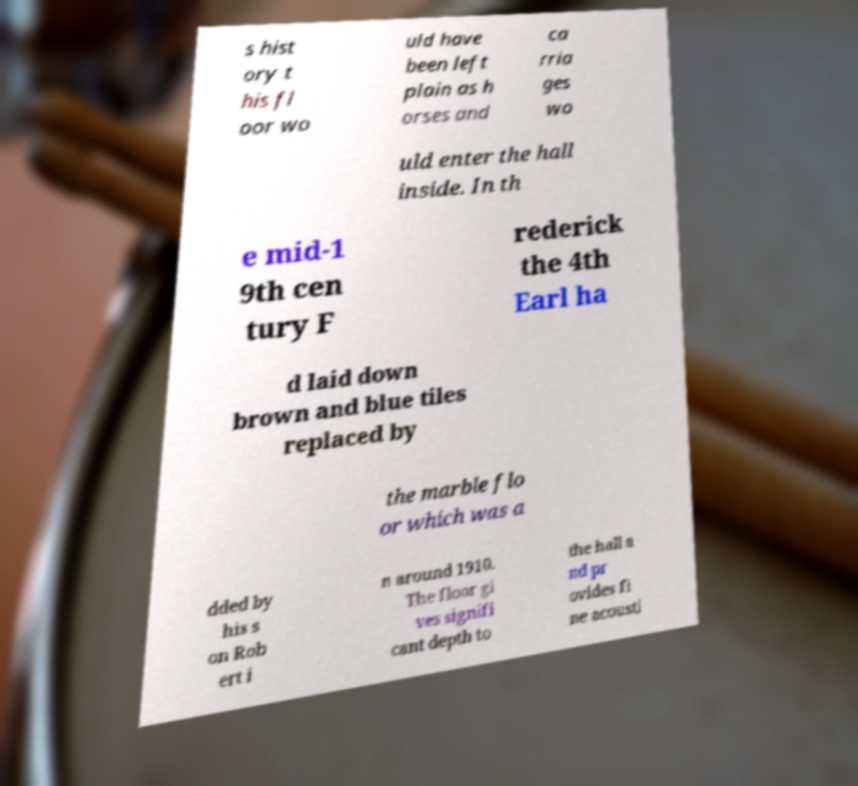For documentation purposes, I need the text within this image transcribed. Could you provide that? s hist ory t his fl oor wo uld have been left plain as h orses and ca rria ges wo uld enter the hall inside. In th e mid-1 9th cen tury F rederick the 4th Earl ha d laid down brown and blue tiles replaced by the marble flo or which was a dded by his s on Rob ert i n around 1910. The floor gi ves signifi cant depth to the hall a nd pr ovides fi ne acousti 